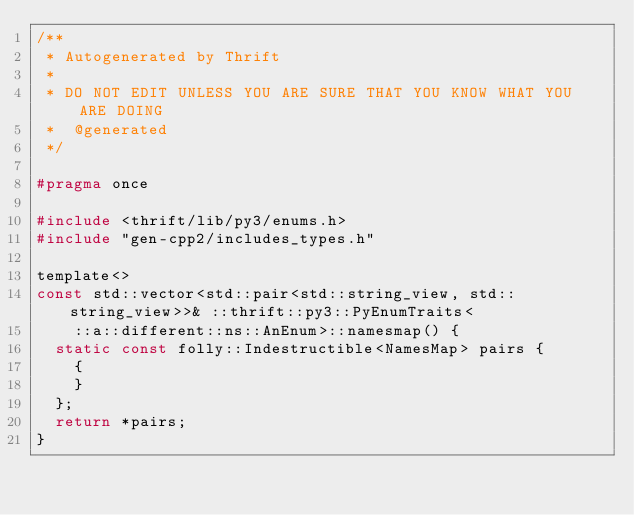<code> <loc_0><loc_0><loc_500><loc_500><_C_>/**
 * Autogenerated by Thrift
 *
 * DO NOT EDIT UNLESS YOU ARE SURE THAT YOU KNOW WHAT YOU ARE DOING
 *  @generated
 */

#pragma once

#include <thrift/lib/py3/enums.h>
#include "gen-cpp2/includes_types.h"

template<>
const std::vector<std::pair<std::string_view, std::string_view>>& ::thrift::py3::PyEnumTraits<
    ::a::different::ns::AnEnum>::namesmap() {
  static const folly::Indestructible<NamesMap> pairs {
    {
    }
  };
  return *pairs;
}

</code> 